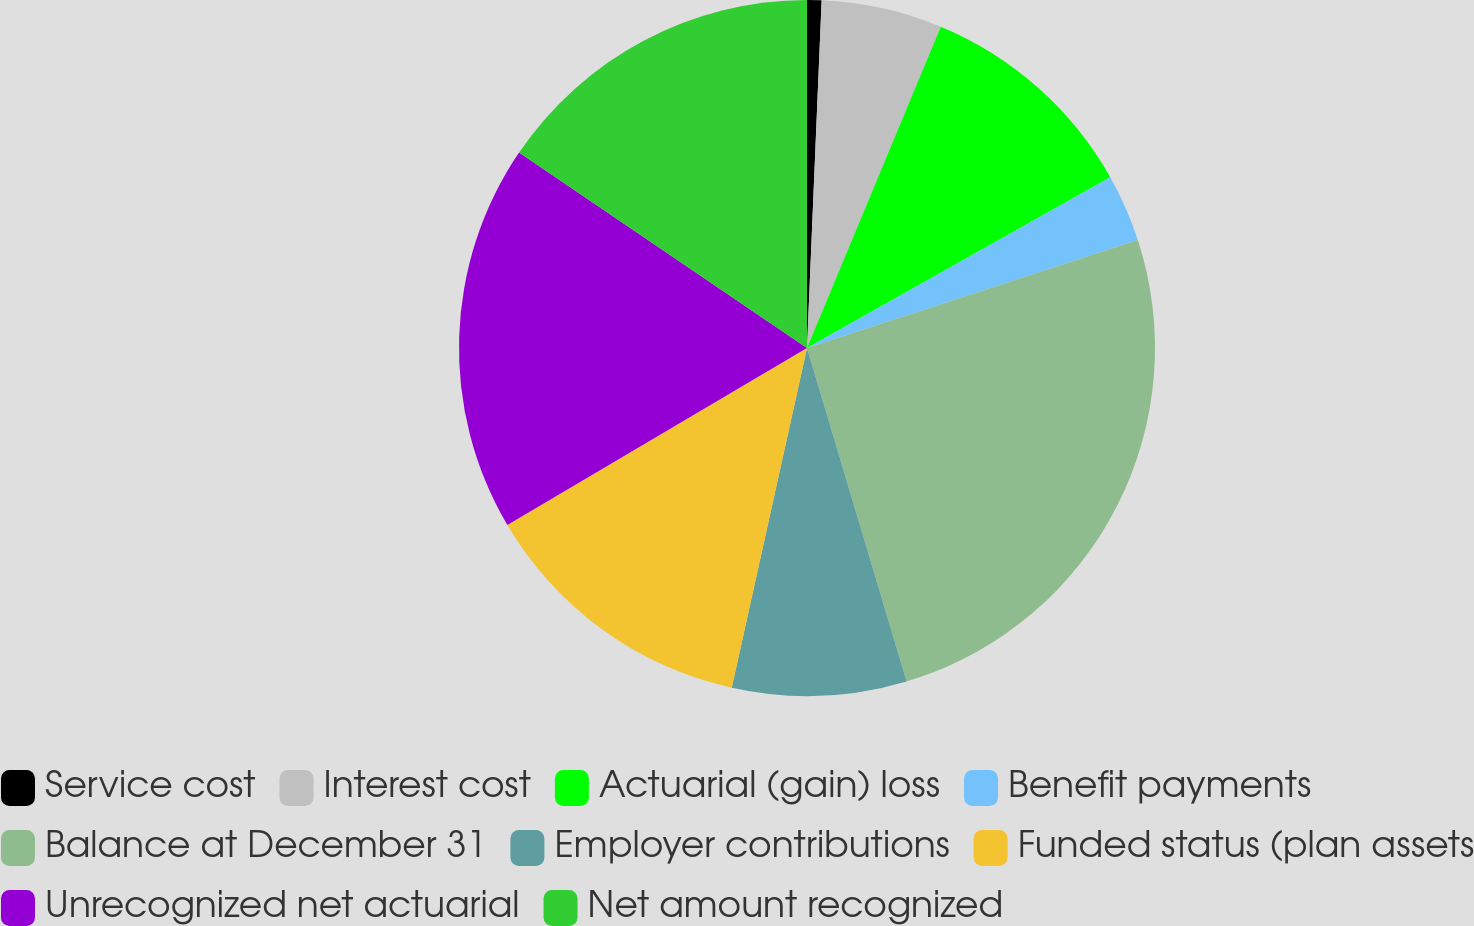Convert chart to OTSL. <chart><loc_0><loc_0><loc_500><loc_500><pie_chart><fcel>Service cost<fcel>Interest cost<fcel>Actuarial (gain) loss<fcel>Benefit payments<fcel>Balance at December 31<fcel>Employer contributions<fcel>Funded status (plan assets<fcel>Unrecognized net actuarial<fcel>Net amount recognized<nl><fcel>0.67%<fcel>5.61%<fcel>10.56%<fcel>3.14%<fcel>25.4%<fcel>8.09%<fcel>13.04%<fcel>17.98%<fcel>15.51%<nl></chart> 